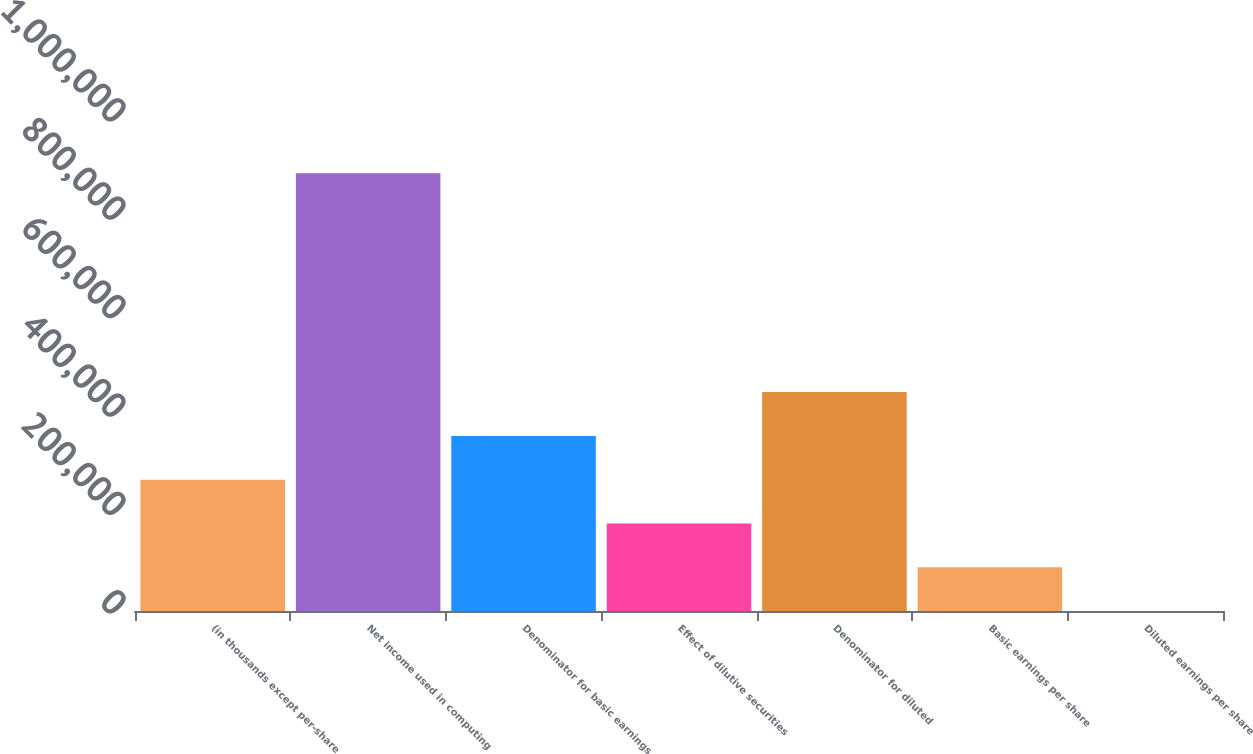Convert chart to OTSL. <chart><loc_0><loc_0><loc_500><loc_500><bar_chart><fcel>(in thousands except per-share<fcel>Net income used in computing<fcel>Denominator for basic earnings<fcel>Effect of dilutive securities<fcel>Denominator for diluted<fcel>Basic earnings per share<fcel>Diluted earnings per share<nl><fcel>266932<fcel>889766<fcel>355908<fcel>177956<fcel>444884<fcel>88979.3<fcel>3<nl></chart> 